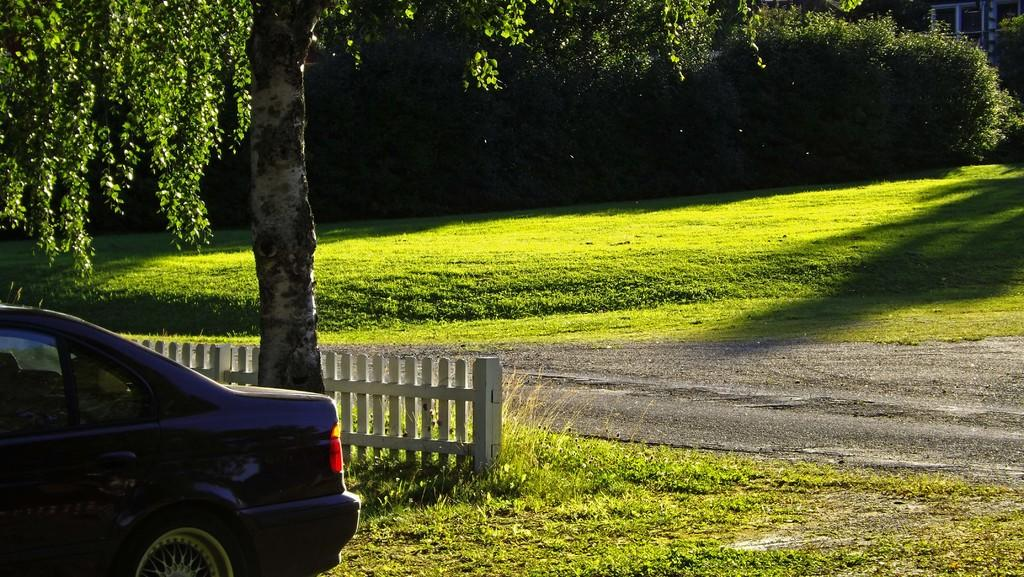What can be seen on the left side of the image? There is a car on the left side of the image. What type of vegetation is visible at the bottom of the image? There is grass visible at the bottom of the image. What is the surface that people might walk on in the image? There is a walkway in the image. What can be seen in the background of the image? There are trees, grass, and buildings in the background of the image. What type of leaf is being used as a form of payment in the image? There is no leaf being used as a form of payment in the image. Can you tell me the name of the governor who is walking on the walkway in the image? There is no governor present in the image, nor is anyone walking on the walkway. 